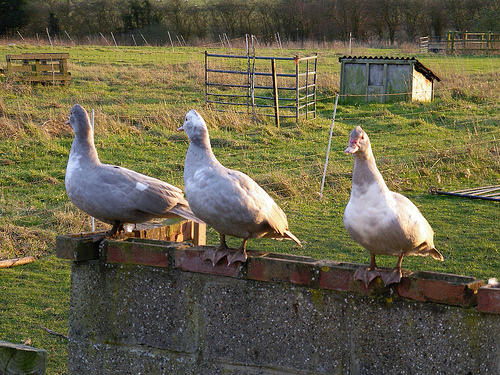<image>
Is the duck on the wall? Yes. Looking at the image, I can see the duck is positioned on top of the wall, with the wall providing support. Is the duck on the wall? Yes. Looking at the image, I can see the duck is positioned on top of the wall, with the wall providing support. 